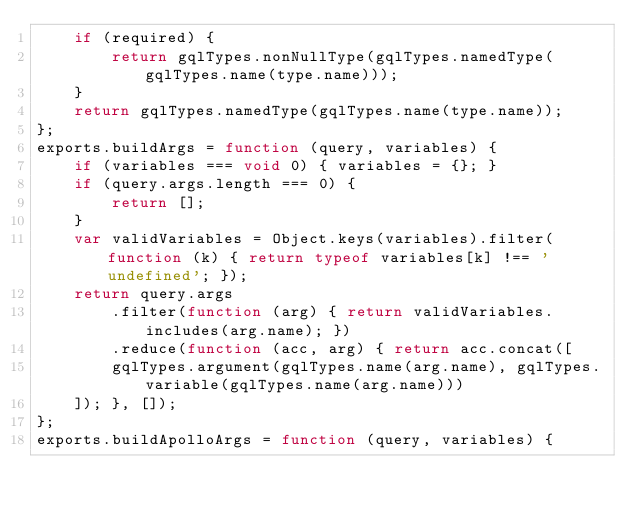<code> <loc_0><loc_0><loc_500><loc_500><_JavaScript_>    if (required) {
        return gqlTypes.nonNullType(gqlTypes.namedType(gqlTypes.name(type.name)));
    }
    return gqlTypes.namedType(gqlTypes.name(type.name));
};
exports.buildArgs = function (query, variables) {
    if (variables === void 0) { variables = {}; }
    if (query.args.length === 0) {
        return [];
    }
    var validVariables = Object.keys(variables).filter(function (k) { return typeof variables[k] !== 'undefined'; });
    return query.args
        .filter(function (arg) { return validVariables.includes(arg.name); })
        .reduce(function (acc, arg) { return acc.concat([
        gqlTypes.argument(gqlTypes.name(arg.name), gqlTypes.variable(gqlTypes.name(arg.name)))
    ]); }, []);
};
exports.buildApolloArgs = function (query, variables) {</code> 